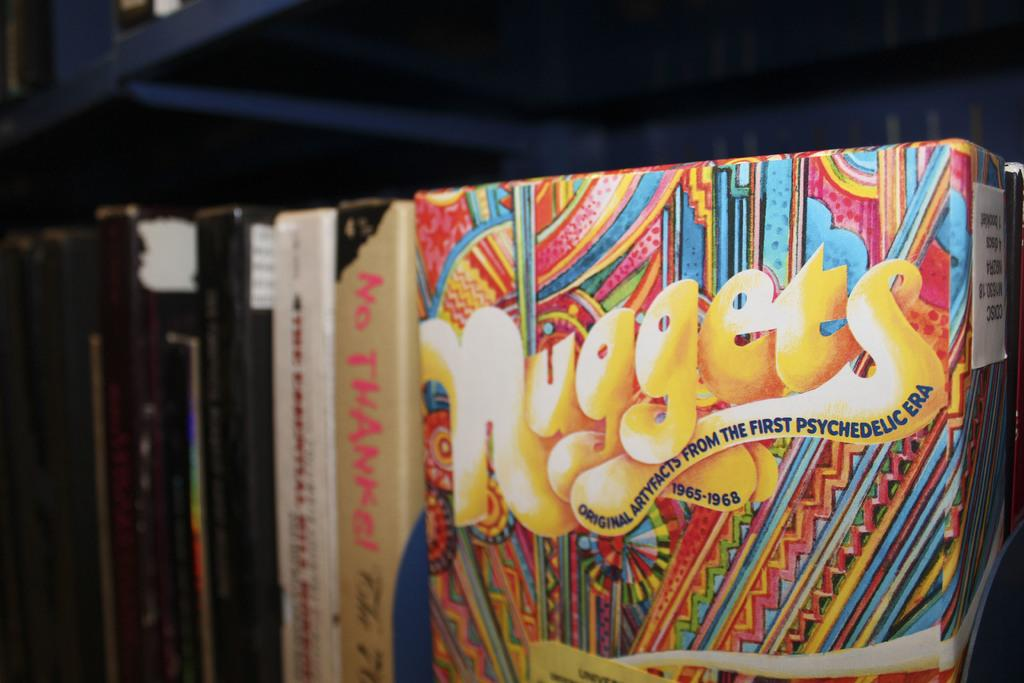<image>
Render a clear and concise summary of the photo. a box next to books that says 'nuggets' on it 